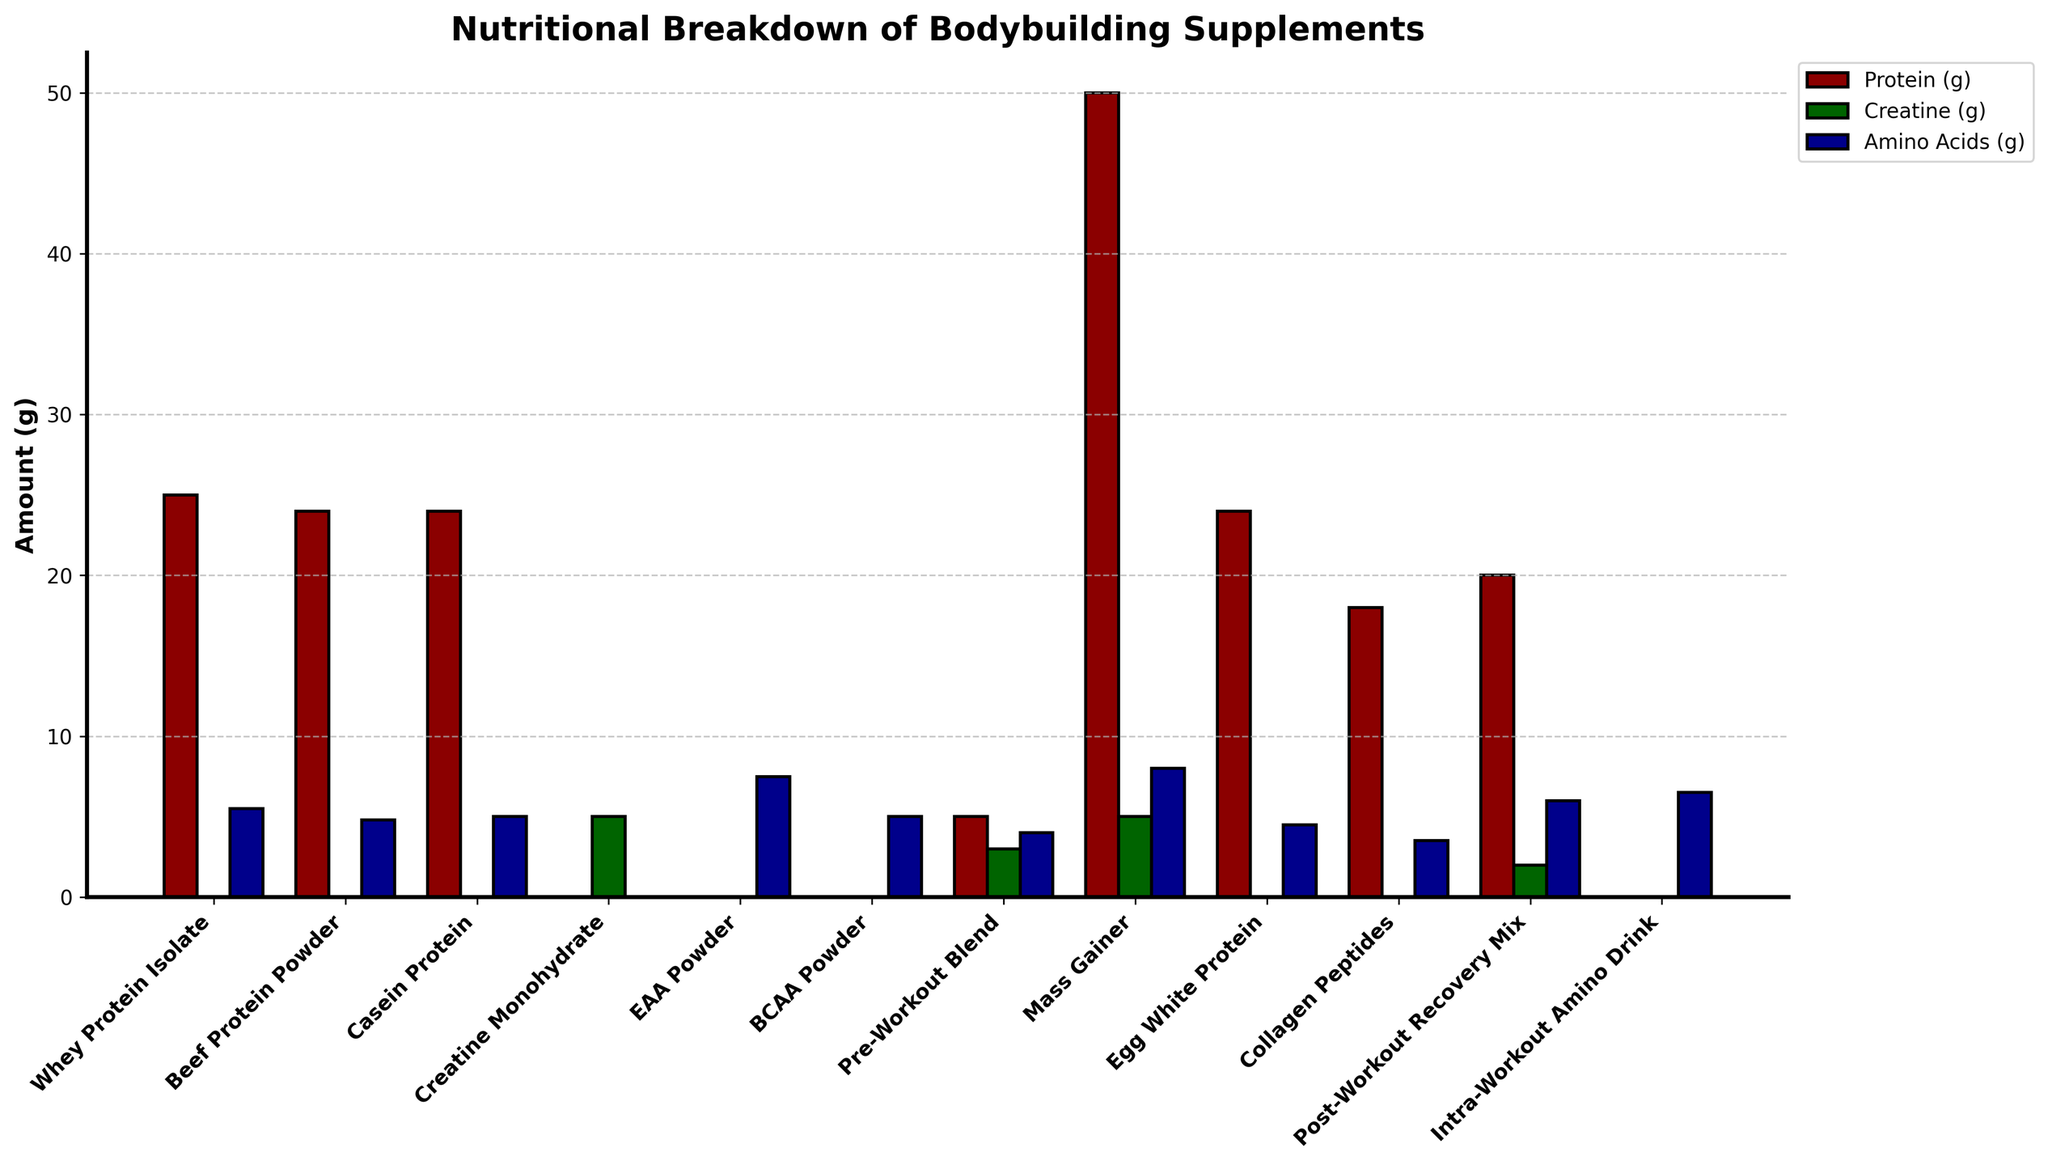Which supplement contains the highest amount of protein? To determine the supplement with the highest amount of protein, look at the height of the bars representing protein for each supplement. The Mass Gainer has the highest bar for protein.
Answer: Mass Gainer Which supplements contain creatine? Check for bars with the color representing creatine. The supplements with creatine are Creatine Monohydrate, Pre-Workout Blend, Mass Gainer, and Post-Workout Recovery Mix.
Answer: Creatine Monohydrate, Pre-Workout Blend, Mass Gainer, Post-Workout Recovery Mix How many supplements contain at least 5 grams of amino acids? Identify bars representing amino acids with heights of at least 5 grams. These supplements are Whey Protein Isolate, EAA Powder, Mass Gainer, Post-Workout Recovery Mix, and Intra-Workout Amino Drink. Count them.
Answer: 5 Which supplement provides the lowest amount of total nutrients (sum of protein, creatine, and amino acids)? Sum the protein, creatine, and amino acids for each supplement and find the lowest total. Collagen Peptides has the lowest sum (18 + 0 + 3.5 = 21.5).
Answer: Collagen Peptides Between Mass Gainer and Casein Protein, which supplement has more combined protein and creatine? Calculate the sum of protein and creatine for both supplements. Mass Gainer has 50g protein + 5g creatine = 55g, while Casein Protein has 24g protein + 0g creatine = 24g. Mass Gainer has more.
Answer: Mass Gainer Which supplement has the highest amount of amino acids? Locate the bar representing amino acids and find the tallest bar. EAA Powder has the highest amount with 7.5 grams.
Answer: EAA Powder How does the amount of creatine in Pre-Workout Blend compare to that in Post-Workout Recovery Mix? Compare the heights of the bars for creatine between these two supplements. Pre-Workout Blend has 3 grams, and Post-Workout Recovery Mix has 2 grams.
Answer: Pre-Workout Blend has more What is the total amount of protein in Whey Protein Isolate, Beef Protein Powder, and Casein Protein combined? Add the protein amounts for these three supplements: 25g (Whey Protein Isolate) + 24g (Beef Protein Powder) + 24g (Casein Protein) = 73g.
Answer: 73 grams What can you say about the protein content relative to creatine and amino acids in Creatine Monohydrate? Look at the bars representing protein, creatine, and amino acids for Creatine Monohydrate. Protein and amino acids are 0 grams, and creatine is 5 grams.
Answer: Creatine only Which supplement offers an equal amount of protein and amino acids? Compare the bars of protein and amino acids for each supplement to find equal heights. None of the supplements have equal grams of protein and amino acids.
Answer: None 